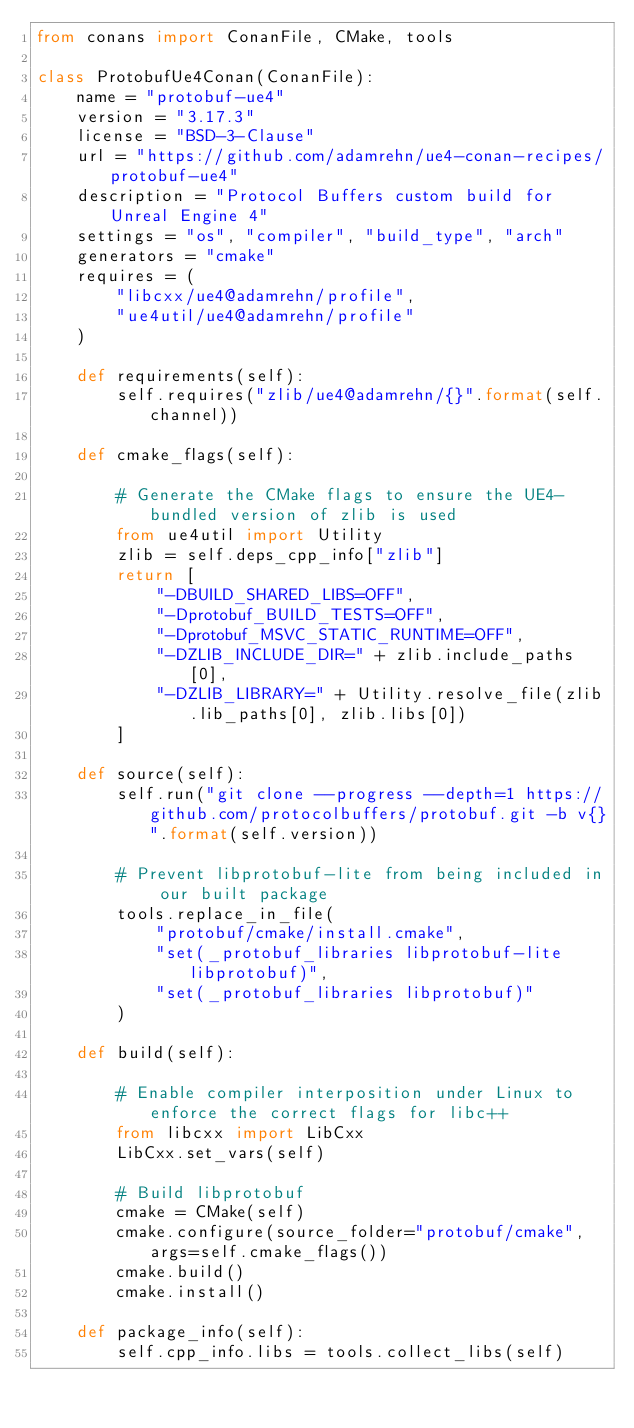<code> <loc_0><loc_0><loc_500><loc_500><_Python_>from conans import ConanFile, CMake, tools

class ProtobufUe4Conan(ConanFile):
    name = "protobuf-ue4"
    version = "3.17.3"
    license = "BSD-3-Clause"
    url = "https://github.com/adamrehn/ue4-conan-recipes/protobuf-ue4"
    description = "Protocol Buffers custom build for Unreal Engine 4"
    settings = "os", "compiler", "build_type", "arch"
    generators = "cmake"
    requires = (
        "libcxx/ue4@adamrehn/profile",
        "ue4util/ue4@adamrehn/profile"
    )
    
    def requirements(self):
        self.requires("zlib/ue4@adamrehn/{}".format(self.channel))
    
    def cmake_flags(self):
        
        # Generate the CMake flags to ensure the UE4-bundled version of zlib is used
        from ue4util import Utility
        zlib = self.deps_cpp_info["zlib"]
        return [
            "-DBUILD_SHARED_LIBS=OFF",
            "-Dprotobuf_BUILD_TESTS=OFF",
            "-Dprotobuf_MSVC_STATIC_RUNTIME=OFF",
            "-DZLIB_INCLUDE_DIR=" + zlib.include_paths[0],
            "-DZLIB_LIBRARY=" + Utility.resolve_file(zlib.lib_paths[0], zlib.libs[0])
        ]
    
    def source(self):
        self.run("git clone --progress --depth=1 https://github.com/protocolbuffers/protobuf.git -b v{}".format(self.version))
        
        # Prevent libprotobuf-lite from being included in our built package
        tools.replace_in_file(
            "protobuf/cmake/install.cmake",
            "set(_protobuf_libraries libprotobuf-lite libprotobuf)",
            "set(_protobuf_libraries libprotobuf)"
        )
    
    def build(self):
        
        # Enable compiler interposition under Linux to enforce the correct flags for libc++
        from libcxx import LibCxx
        LibCxx.set_vars(self)
        
        # Build libprotobuf
        cmake = CMake(self)
        cmake.configure(source_folder="protobuf/cmake", args=self.cmake_flags())
        cmake.build()
        cmake.install()
    
    def package_info(self):
        self.cpp_info.libs = tools.collect_libs(self)
</code> 